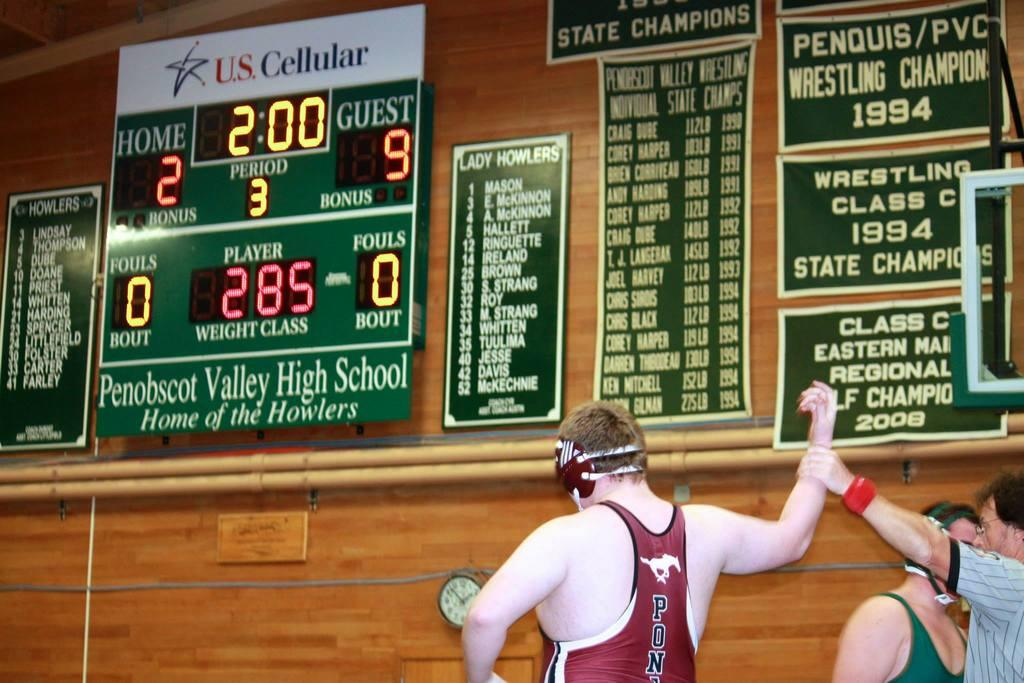<image>
Offer a succinct explanation of the picture presented. Three wrestlers where the referree is holding up the right arm of the wrestler dressed in red pony tank top. 